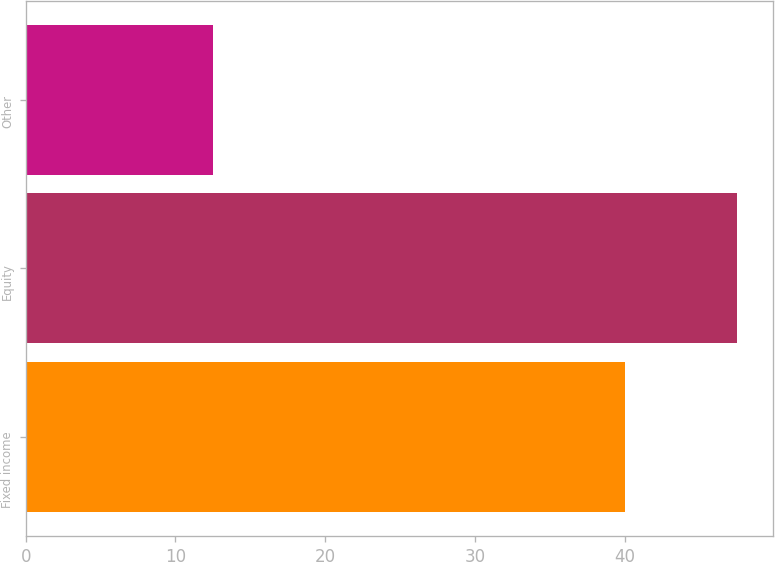Convert chart. <chart><loc_0><loc_0><loc_500><loc_500><bar_chart><fcel>Fixed income<fcel>Equity<fcel>Other<nl><fcel>40<fcel>47.5<fcel>12.5<nl></chart> 